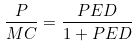Convert formula to latex. <formula><loc_0><loc_0><loc_500><loc_500>\frac { P } { M C } = \frac { P E D } { 1 + P E D }</formula> 